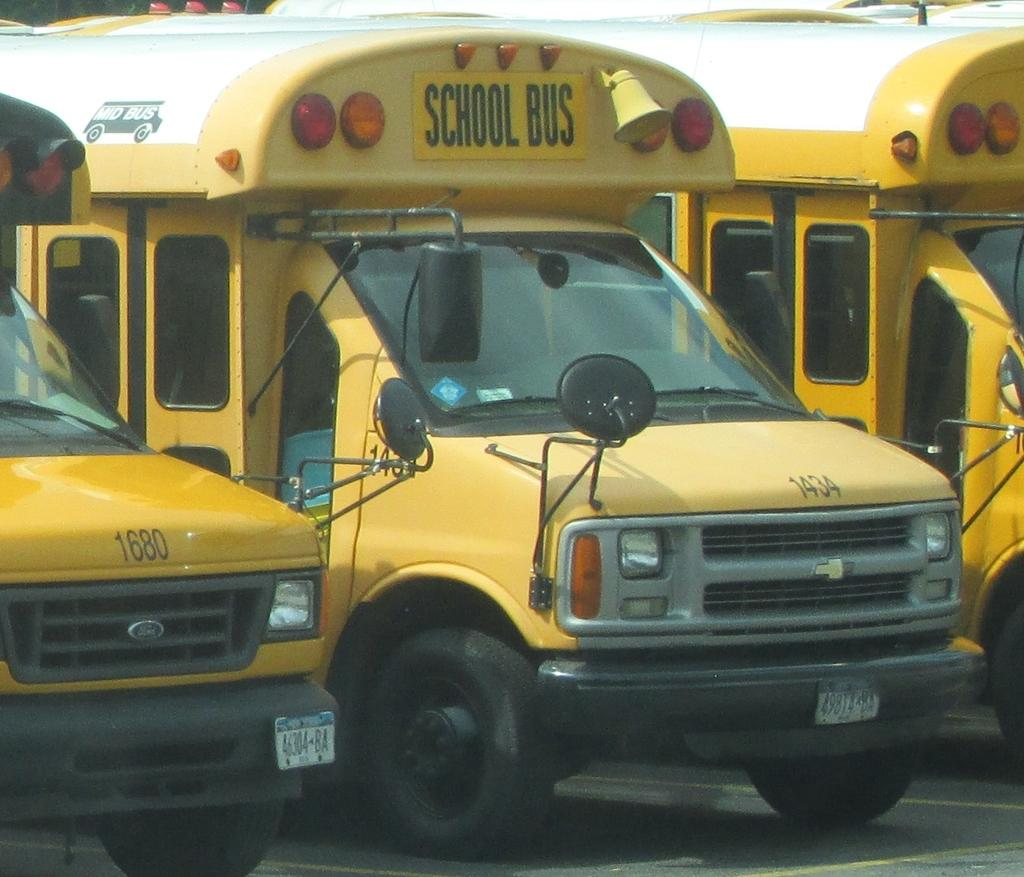<image>
Describe the image concisely. Numbered yellow school buses are parked side by side, with 1680 a neighbor to 1434. 